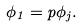Convert formula to latex. <formula><loc_0><loc_0><loc_500><loc_500>\phi _ { 1 } = p \phi _ { j } .</formula> 